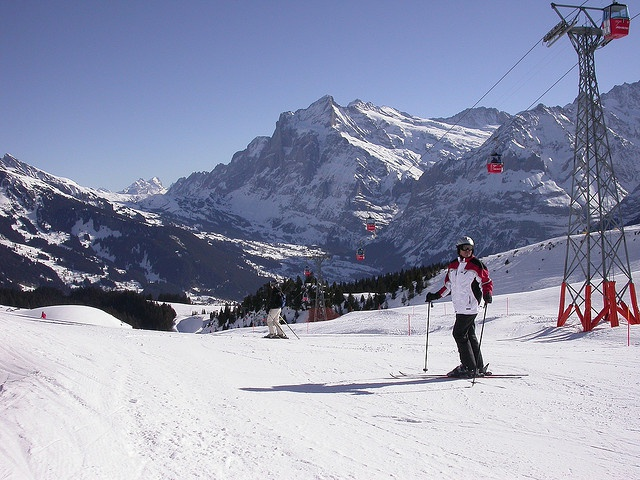Describe the objects in this image and their specific colors. I can see people in gray, black, and darkgray tones, people in gray, black, darkgray, and lightgray tones, skis in gray, lightgray, black, and darkgray tones, and people in gray, maroon, and brown tones in this image. 